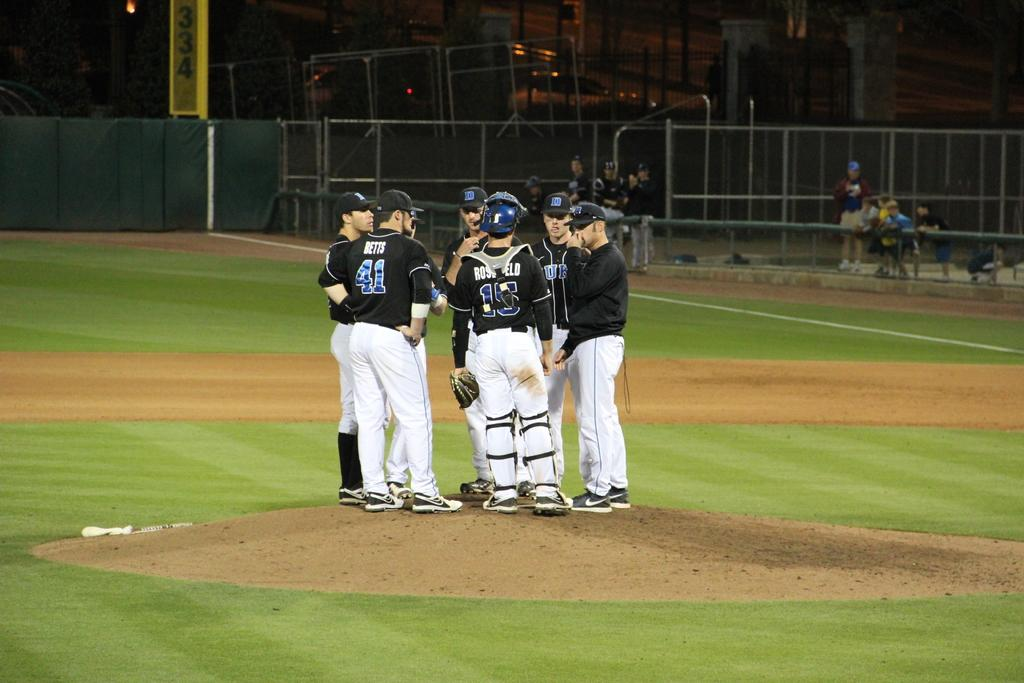<image>
Give a short and clear explanation of the subsequent image. One of the sevral players on the field has the number 41 on his back 